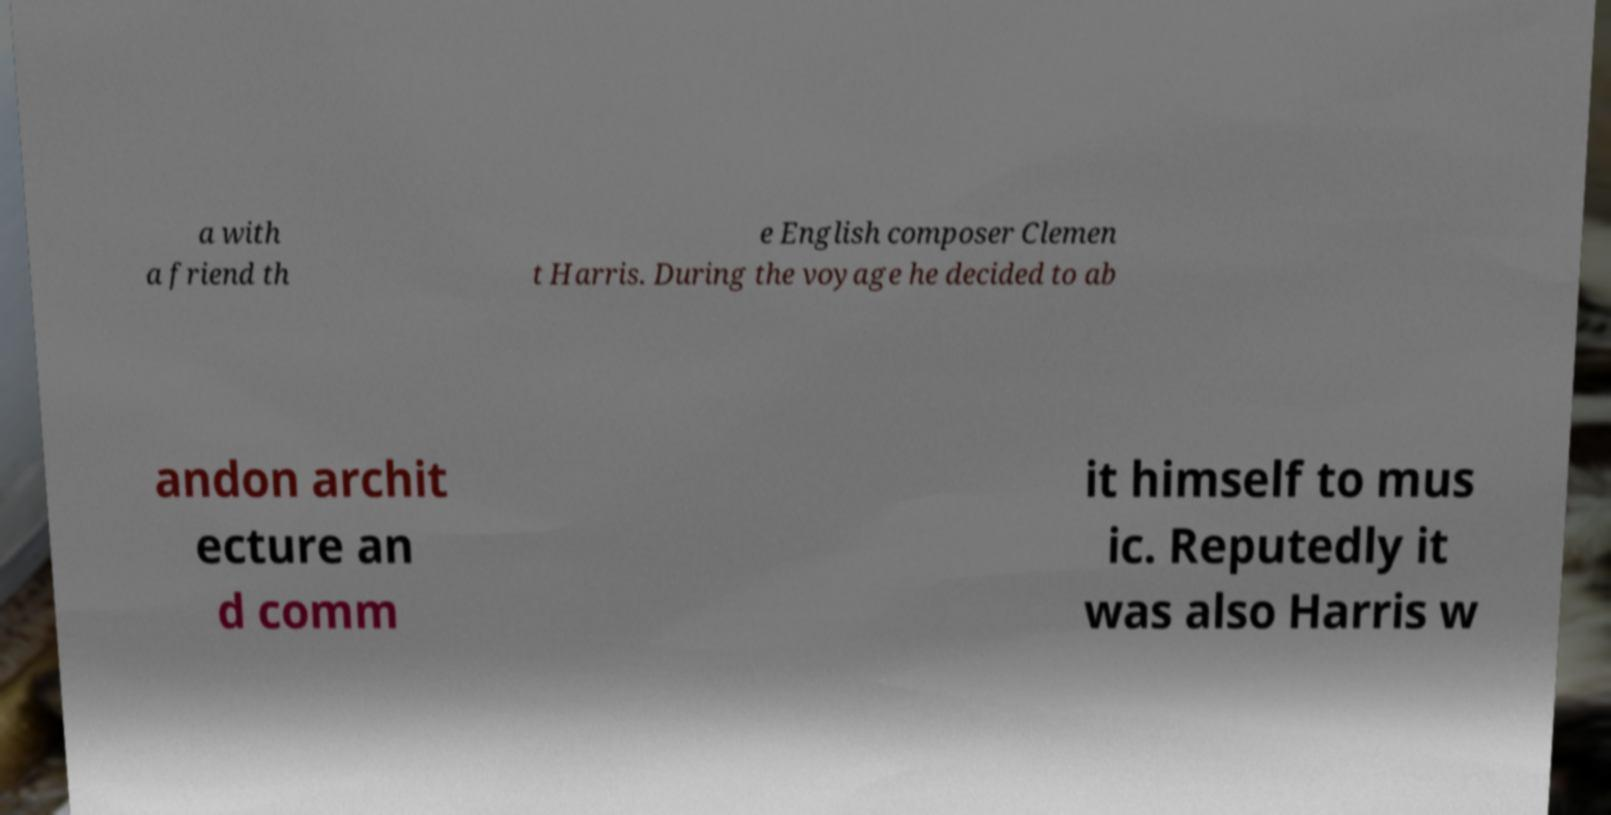Please identify and transcribe the text found in this image. a with a friend th e English composer Clemen t Harris. During the voyage he decided to ab andon archit ecture an d comm it himself to mus ic. Reputedly it was also Harris w 